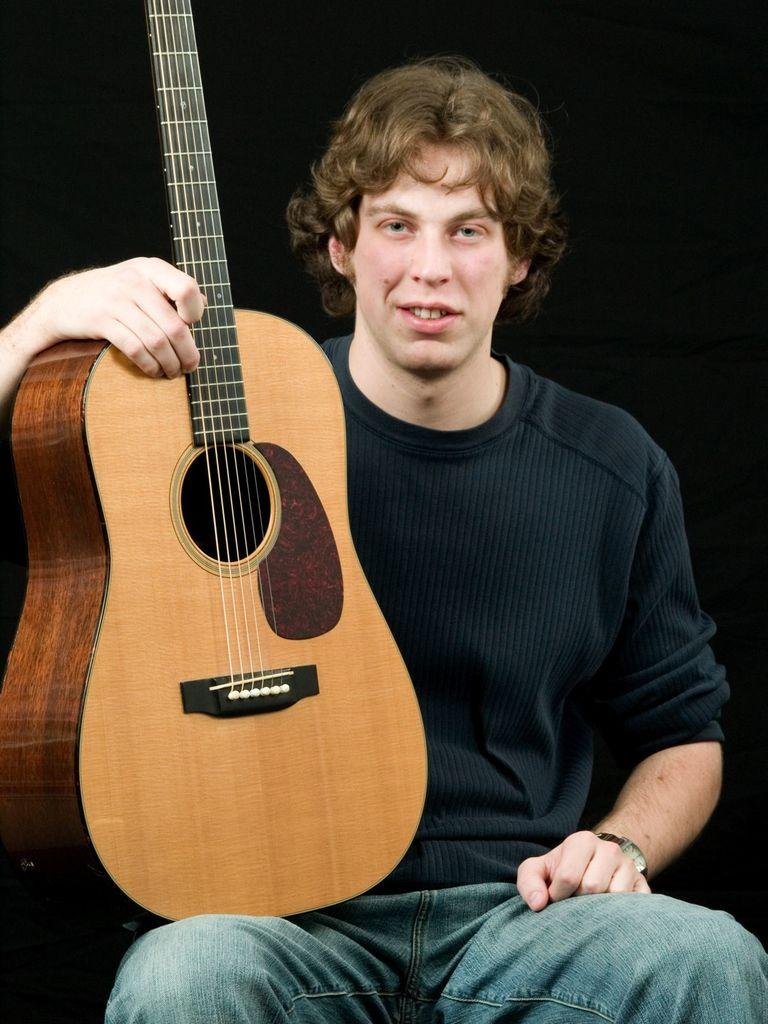What is the main subject of the image? There is a man in the image. What is the man wearing on his upper body? The man is wearing a black shirt. What accessory is the man wearing on his wrist? The man is wearing a watch. What type of pants is the man wearing? The man is wearing jeans pants. What is the man's posture in the image? The man is sitting in a chair. What object is the man holding in the image? The man is holding a guitar. Where is the loaf of bread located in the image? There is no loaf of bread present in the image. Can you see a stream in the background of the image? No, there is no stream visible in the image. Is there a cactus near the man in the image? There is no cactus present in the image. 